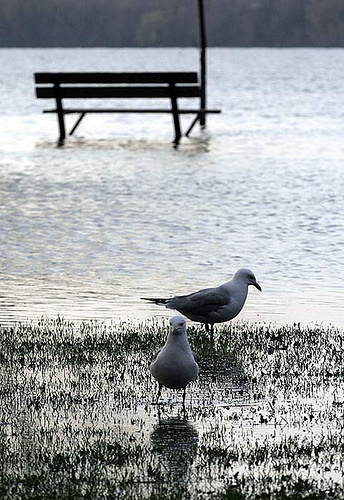Describe the objects in this image and their specific colors. I can see bench in gray, black, lightgray, and darkgray tones, bird in gray, black, and darkgray tones, and bird in gray and black tones in this image. 